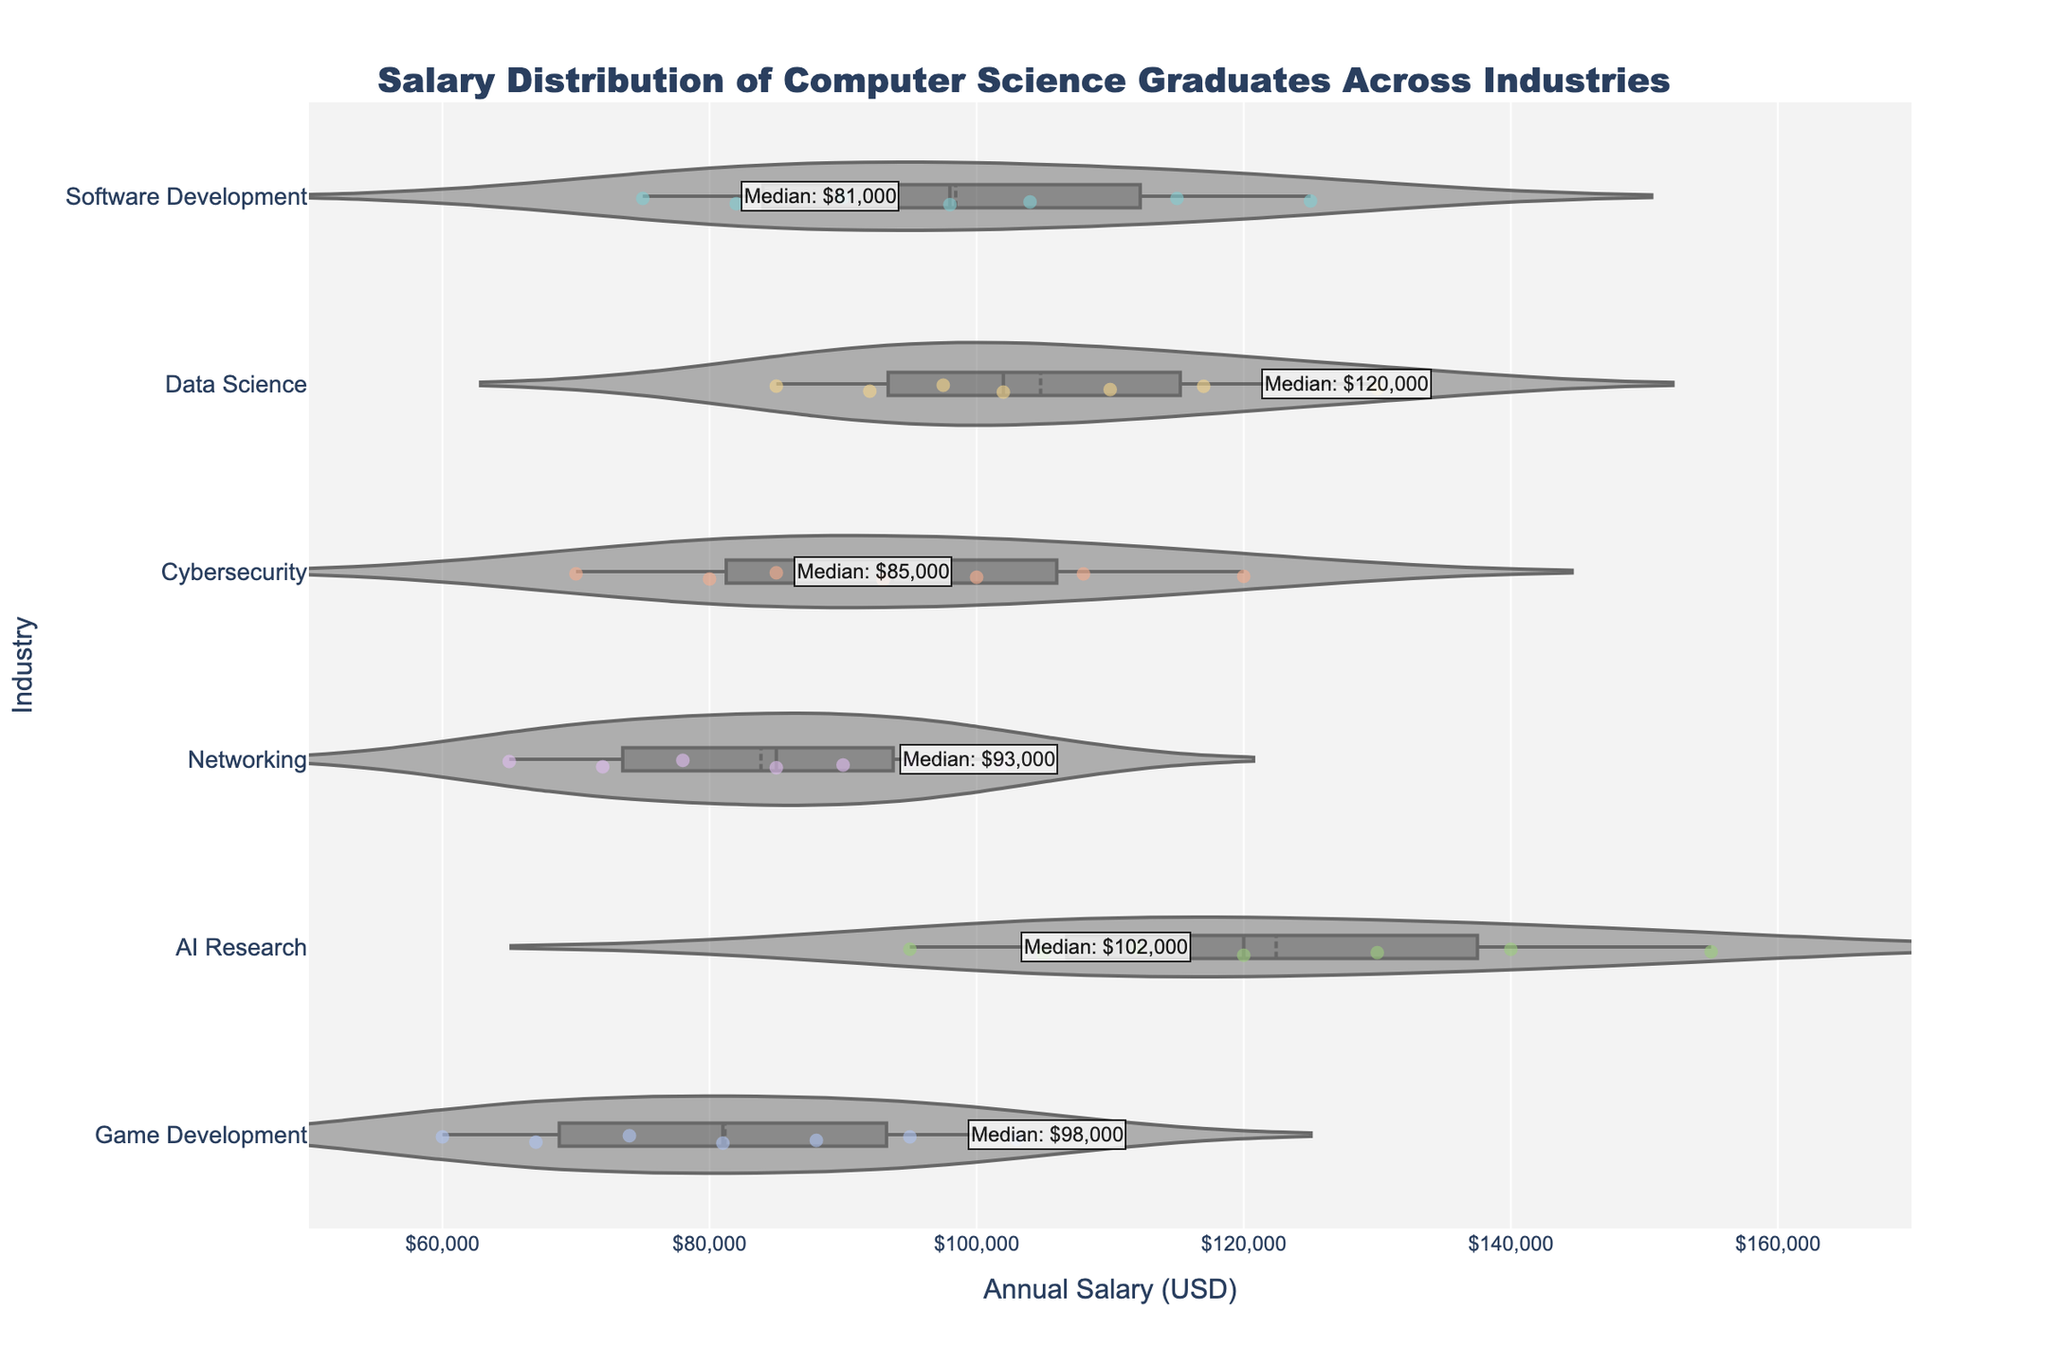What's the title of the figure? The title of the figure is displayed at the top center, which indicates what the plot is about.
Answer: Salary Distribution of Computer Science Graduates Across Industries What is the median salary for Software Development? The median salary for Software Development can be identified by the annotation on the corresponding violin plot. The median value is labeled as "Median: $98,000."
Answer: $98,000 Which industry has the lowest recorded salary, and what is that salary? The lowest recorded salary can be found at the leftmost edge of any violin plot. The lowest value, located on the Game Development plot, is $60,000.
Answer: Game Development, $60,000 How many industries have a median salary higher than $100,000? By inspecting the median annotations on each violin plot, we can see that the industries with median salaries higher than $100,000 are Data Science ($102,000), AI Research ($120,000), and Cybersecurity ($100,000). Thus, there are three such industries.
Answer: 3 Compare the median salary of Cybersecurity with Data Science. Which one is higher and by how much? The median salary for Cybersecurity is $100,000 and for Data Science is $102,000. The difference can be calculated as $102,000 - $100,000 = $2,000.
Answer: Data Science is higher by $2,000 Which industry has the greatest range in salaries? By analyzing the length of the violin plots from their minimum to maximum salary, we see that AI Research has the longest spread from $95,000 to $155,000, making its range $60,000.
Answer: AI Research How does the median salary of Game Development compare to that of Networking? The median salary for Game Development is $81,000, while the median salary for Networking is $85,000. Networking has a higher median by $4,000.
Answer: Networking is higher by $4,000 Which industry has the widest spread of salaries in the interquartile range (IQR)? The interquartile range can be observed from the width of the violin plot around the box plot section (middle 50%). Data Science displays the widest IQR as the interquartile box is significantly wider than the others.
Answer: Data Science What's the highest recorded salary for AI Research and how does it compare to the highest salary in Software Development? The highest recorded salary for AI Research is $155,000, while for Software Development it is $125,000. AI Research's highest salary is higher by $30,000.
Answer: AI Research is higher by $30,000 